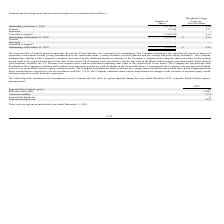According to Telkonet's financial document, What does the expected life of awards granted represent? the period of time that they are expected to be outstanding. The document states: "The expected life of awards granted represents the period of time that they are expected to be outstanding. The Company determines the expected life b..." Also, How is the volatility of the Company's common stock estimated? based on the calculated historical volatility of the Company’s common stock using the share price data for the trailing period equal to the expected term prior to the date of the award. The document states: "ates the volatility of the Company’s common stock based on the calculated historical volatility of the Company’s common stock using the share price da..." Also, What is the valuation model used by the Company? the Black-Scholes option valuation model. The document states: "Company bases the risk-free interest rate used in the Black-Scholes option valuation model on the implied yield currently available on U.S. Treasury z..." Also, can you calculate: What is the percentage change in the outstanding number of shares from January 1, 2018 to December 31, 2018? To answer this question, I need to perform calculations using the financial data. The calculation is: (3,349,793-4,376,474)/4,376,474, which equals -23.46 (percentage). This is based on the information: "Outstanding at December 31, 2018 3,349,793 $ 0.16 Outstanding at January 1, 2018 4,376,474 $ 0.16..." The key data points involved are: 3,349,793, 4,376,474. Additionally, Which stock option has the highest weighted average exercise price per share in 2018? According to the financial document, granted. The relevant text states: "Granted 67,394 0.17..." Also, can you calculate: What is the change in the outstanding number of shares from December 31, 2018 to December 31, 2019? I cannot find a specific answer to this question in the financial document. 